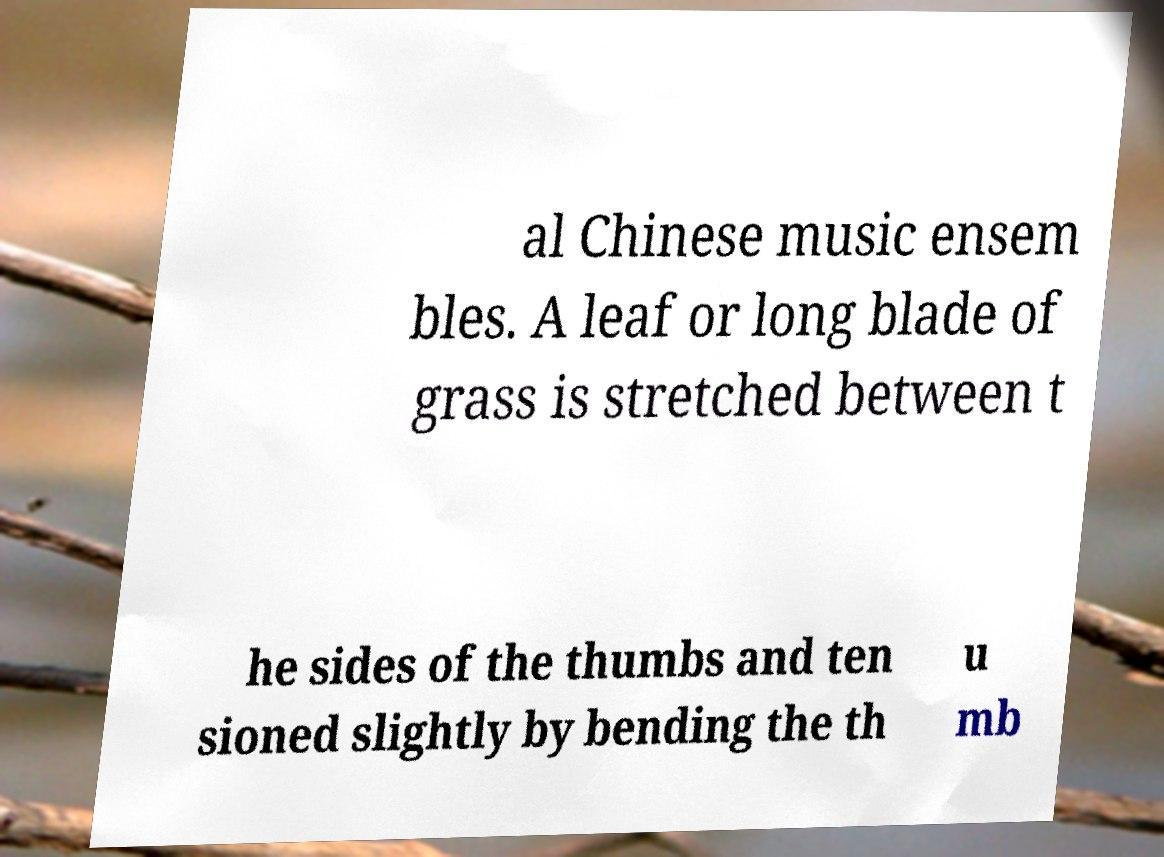For documentation purposes, I need the text within this image transcribed. Could you provide that? al Chinese music ensem bles. A leaf or long blade of grass is stretched between t he sides of the thumbs and ten sioned slightly by bending the th u mb 